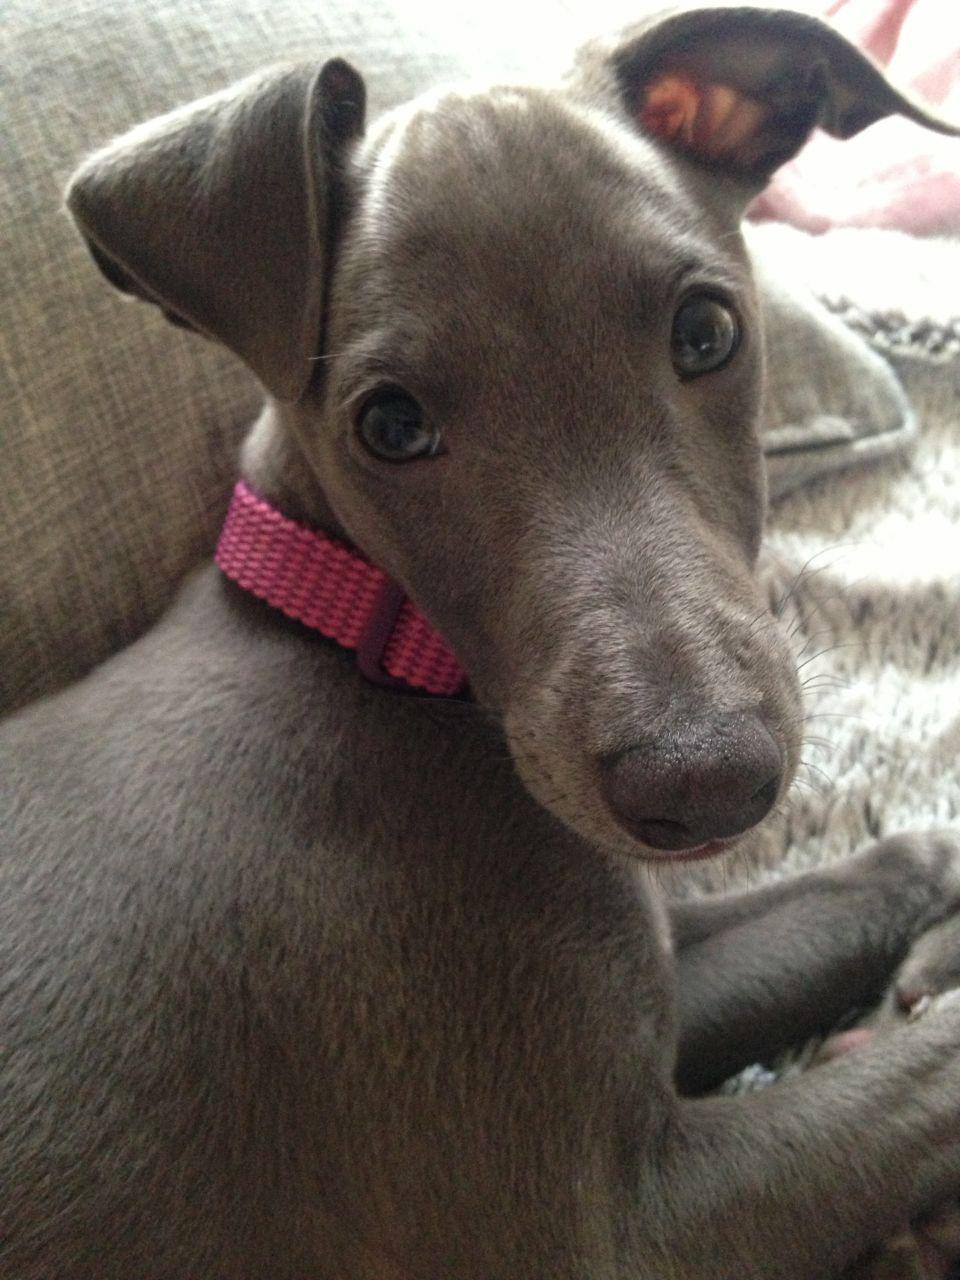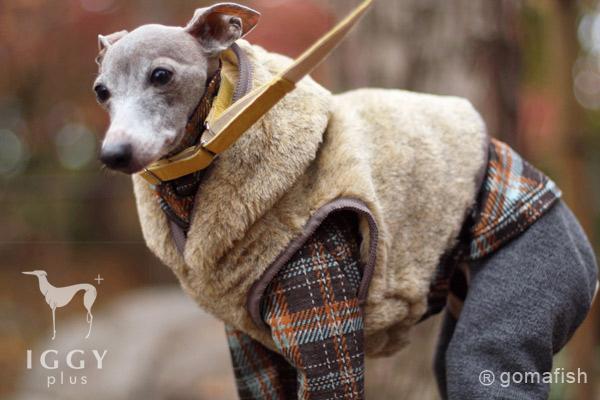The first image is the image on the left, the second image is the image on the right. Considering the images on both sides, is "The combined images include a hound wearing a pink collar and the images include an item of apparel worn by a dog that is not a collar." valid? Answer yes or no. Yes. 